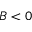<formula> <loc_0><loc_0><loc_500><loc_500>B < 0</formula> 